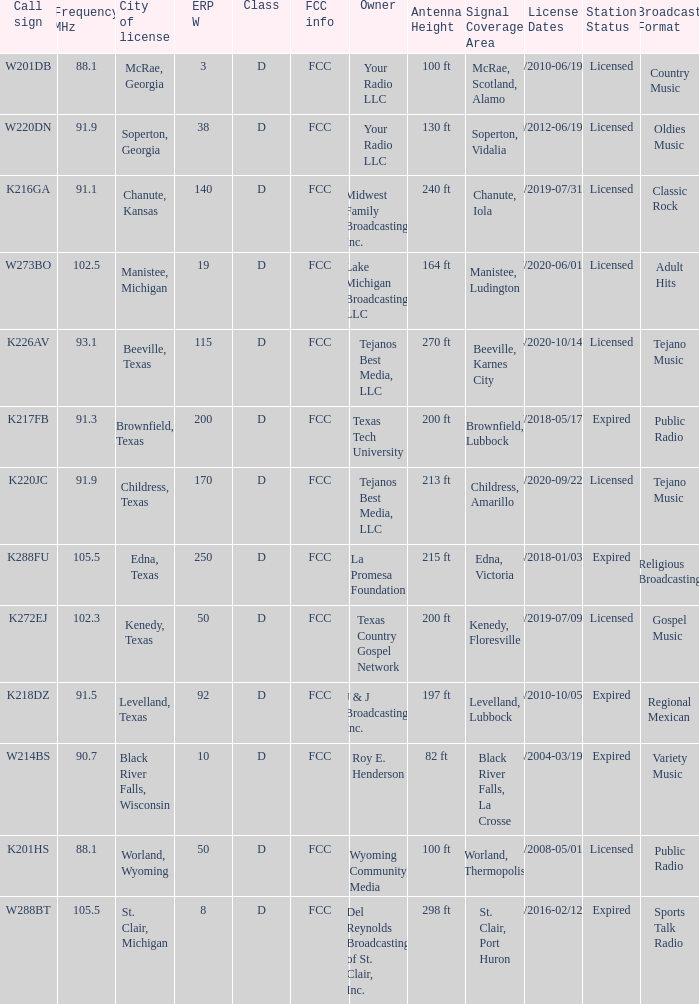What is Call Sign, when City of License is Brownfield, Texas? K217FB. 